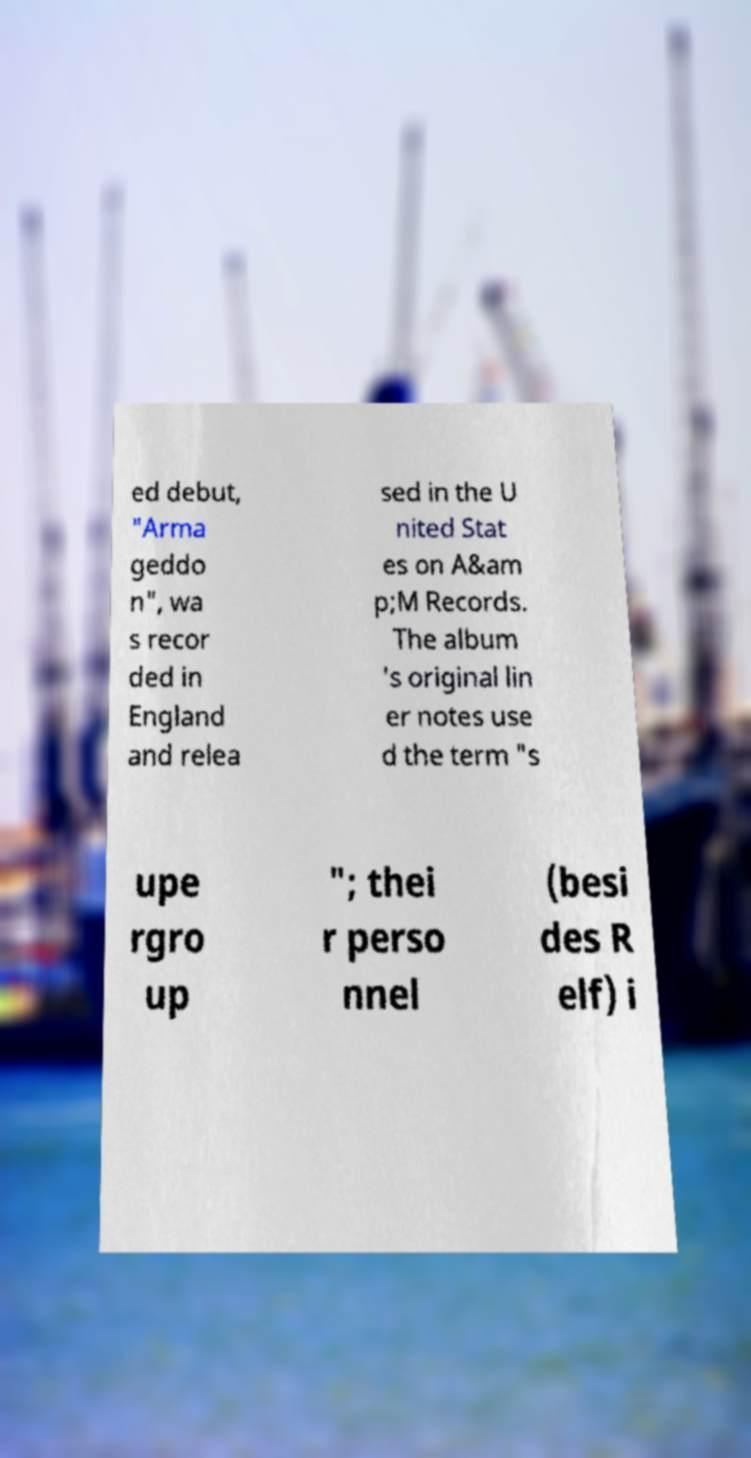Could you assist in decoding the text presented in this image and type it out clearly? ed debut, "Arma geddo n", wa s recor ded in England and relea sed in the U nited Stat es on A&am p;M Records. The album 's original lin er notes use d the term "s upe rgro up "; thei r perso nnel (besi des R elf) i 